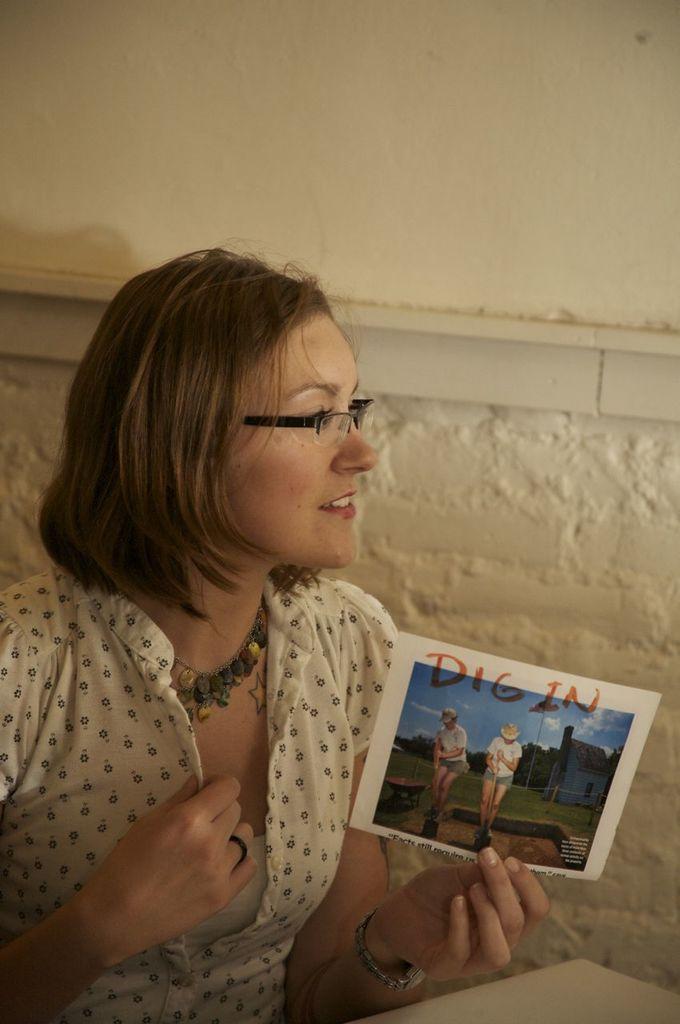Could you give a brief overview of what you see in this image? This image is taken indoors. In the background there is a wall. At the bottom of the image there is a table. On the left side of the image a woman is sitting and she is holding a photo in her hand. 